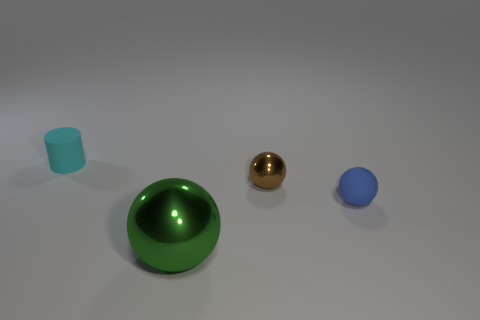Are there any objects in the image that reflect light differently compared to others? Yes, the golden ball in the middle reflects light more intensely and has a mirror-like finish, compared to the large green sphere and the smaller blue and cyan objects, which have more diffuse reflections. 